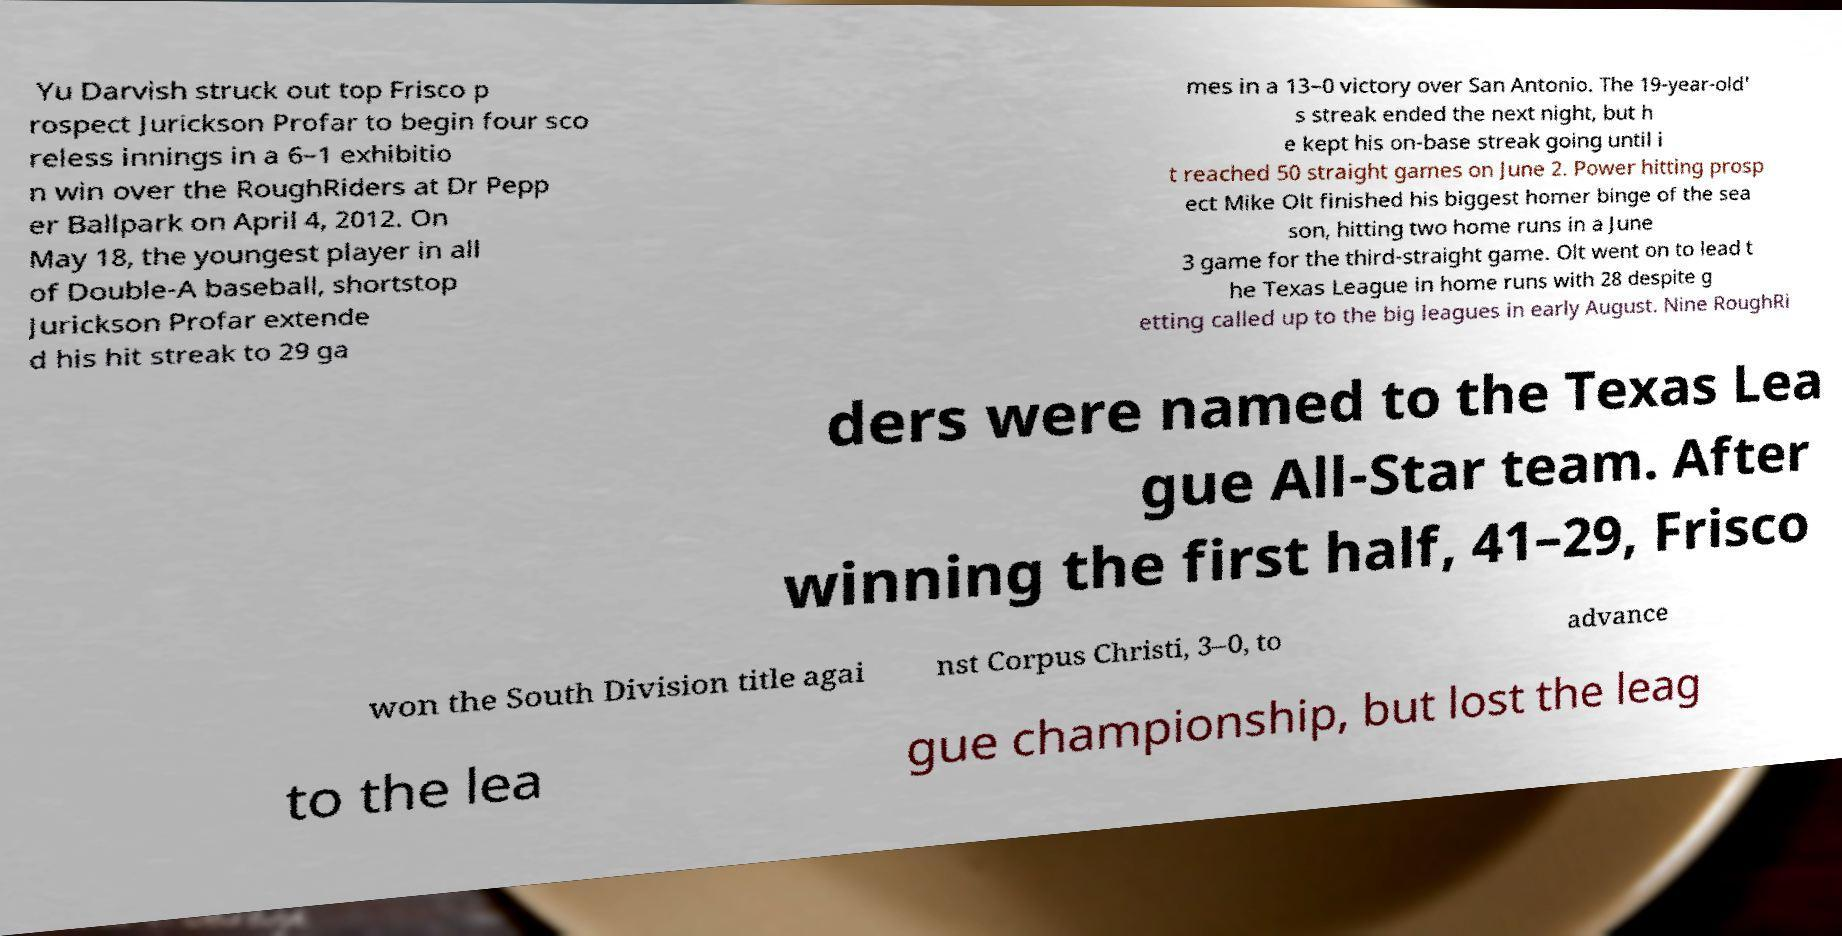Please read and relay the text visible in this image. What does it say? Yu Darvish struck out top Frisco p rospect Jurickson Profar to begin four sco reless innings in a 6–1 exhibitio n win over the RoughRiders at Dr Pepp er Ballpark on April 4, 2012. On May 18, the youngest player in all of Double-A baseball, shortstop Jurickson Profar extende d his hit streak to 29 ga mes in a 13–0 victory over San Antonio. The 19-year-old' s streak ended the next night, but h e kept his on-base streak going until i t reached 50 straight games on June 2. Power hitting prosp ect Mike Olt finished his biggest homer binge of the sea son, hitting two home runs in a June 3 game for the third-straight game. Olt went on to lead t he Texas League in home runs with 28 despite g etting called up to the big leagues in early August. Nine RoughRi ders were named to the Texas Lea gue All-Star team. After winning the first half, 41–29, Frisco won the South Division title agai nst Corpus Christi, 3–0, to advance to the lea gue championship, but lost the leag 